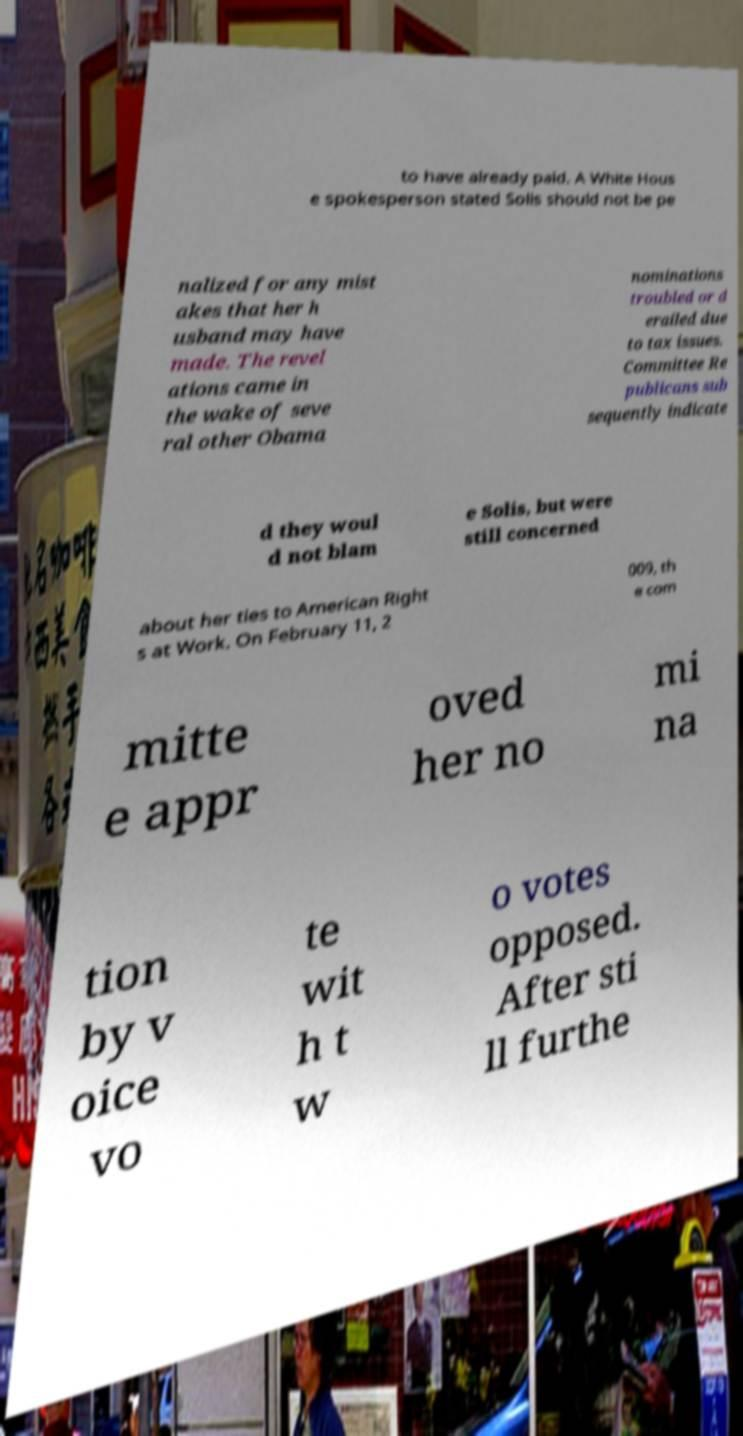Can you read and provide the text displayed in the image?This photo seems to have some interesting text. Can you extract and type it out for me? to have already paid. A White Hous e spokesperson stated Solis should not be pe nalized for any mist akes that her h usband may have made. The revel ations came in the wake of seve ral other Obama nominations troubled or d erailed due to tax issues. Committee Re publicans sub sequently indicate d they woul d not blam e Solis, but were still concerned about her ties to American Right s at Work. On February 11, 2 009, th e com mitte e appr oved her no mi na tion by v oice vo te wit h t w o votes opposed. After sti ll furthe 